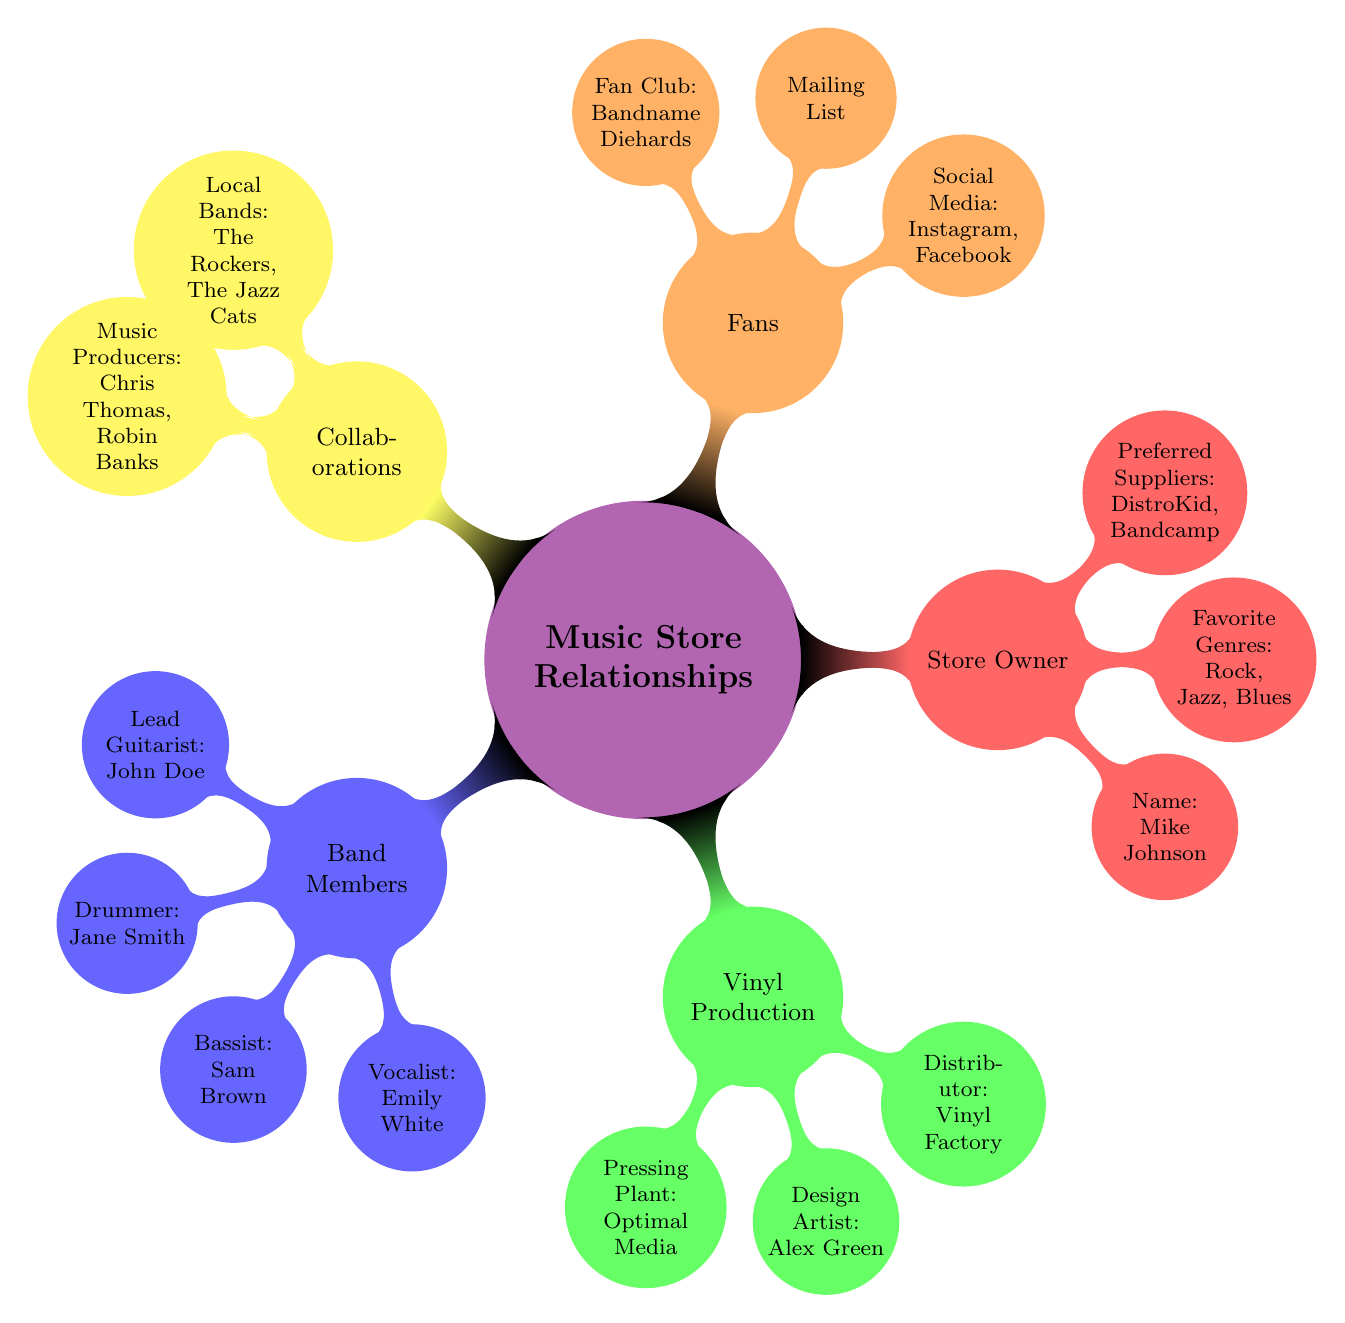What is the name of the Lead Guitarist in the band? The diagram lists the band members, and under the "Lead Guitarist" node, the name "John Doe" is specified.
Answer: John Doe Who are the Preferred Suppliers of the Store Owner? The "Store Owner" section in the diagram indicates that the Preferred Suppliers are identified as "DistroKid" and "Bandcamp."
Answer: DistroKid, Bandcamp How many members are in the band? The diagram explicitly lists four band members: Lead Guitarist, Drummer, Bassist, and Vocalist. Therefore, we count those to ascertain the total number of nodes under "Band Members."
Answer: 4 What is the favorite genre of the Store Owner? From the "Store Owner" section, it specifies "Rock, Jazz, Blues" as the favorite genres by listing them directly under that node.
Answer: Rock, Jazz, Blues Which vinyl production company is listed as the Pressing Plant? The "Vinyl Production" segment of the diagram has a node labeled "Pressing Plant," which mentions "Optimal Media" as the specific company.
Answer: Optimal Media How many local bands are collaborating? Under the "Collaborations" category, the node for "Local Bands" lists two bands: "The Rockers" and "The Jazz Cats." Therefore, we count those to answer the question.
Answer: 2 What is the name of the Fan Club? The "Fans" branch of the diagram indicates that the name of the Fan Club is "Bandname Diehards," which is presented beneath the Fan Club node.
Answer: Bandname Diehards Who is the Design Artist for vinyl production? Within the "Vinyl Production" section, the "Design Artist" node specifically mentions "Alex Green" as the designer associated with the production.
Answer: Alex Green What social media platform is used by the band? The "Fans" section includes a "Social Media" node that showcases both Instagram and Facebook as the platforms used by the band.
Answer: Instagram, Facebook 